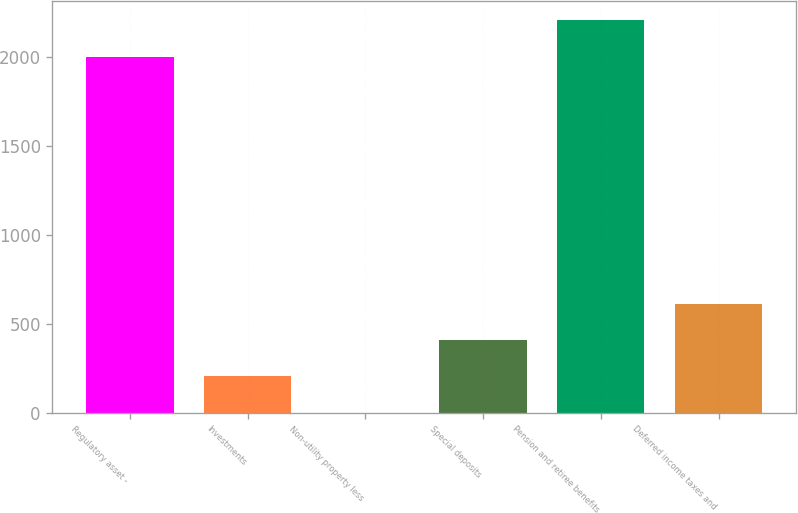Convert chart to OTSL. <chart><loc_0><loc_0><loc_500><loc_500><bar_chart><fcel>Regulatory asset -<fcel>Investments<fcel>Non-utility property less<fcel>Special deposits<fcel>Pension and retiree benefits<fcel>Deferred income taxes and<nl><fcel>1999<fcel>204.9<fcel>1<fcel>408.8<fcel>2202.9<fcel>612.7<nl></chart> 